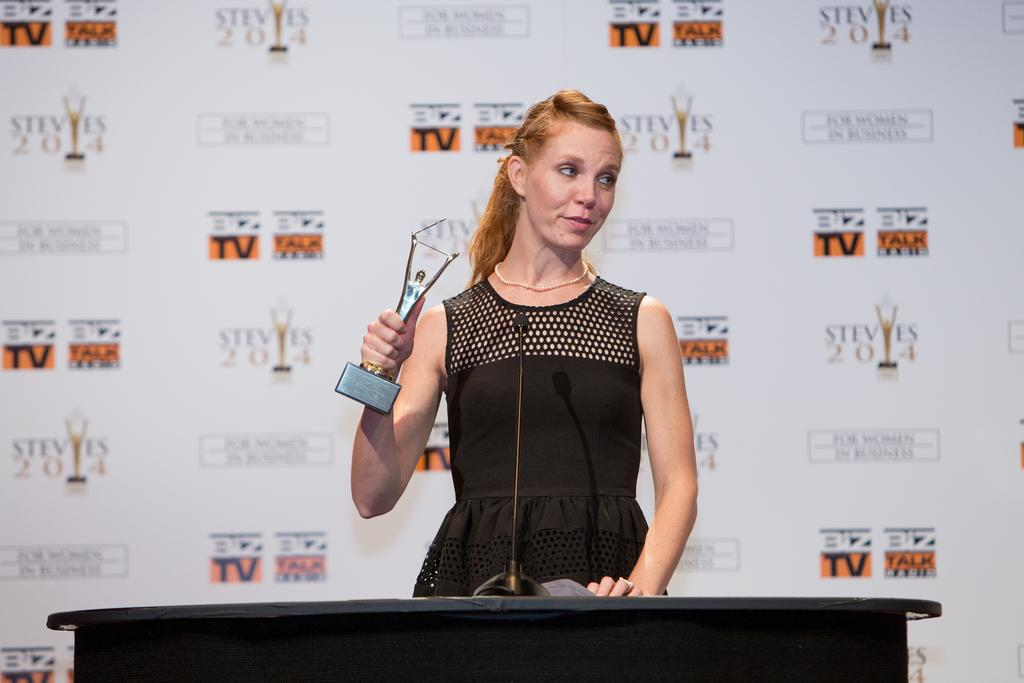Who is the main subject in the image? There is a woman in the image. What is the woman holding in her hand? The woman is holding a trophy in her hand. What is the woman's posture in the image? The woman is standing in the image. What is the woman wearing? The woman is wearing a black dress. What other objects can be seen in the image? There is a podium with a microphone in the image. What is visible in the background of the image? There is a hoarding in the background of the image. What type of grass is growing around the woman's feet in the image? There is no grass visible in the image; the woman is standing on a surface that is not grass. 